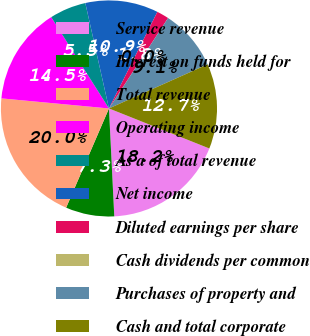Convert chart to OTSL. <chart><loc_0><loc_0><loc_500><loc_500><pie_chart><fcel>Service revenue<fcel>Interest on funds held for<fcel>Total revenue<fcel>Operating income<fcel>As a of total revenue<fcel>Net income<fcel>Diluted earnings per share<fcel>Cash dividends per common<fcel>Purchases of property and<fcel>Cash and total corporate<nl><fcel>18.18%<fcel>7.27%<fcel>20.0%<fcel>14.54%<fcel>5.46%<fcel>10.91%<fcel>1.82%<fcel>0.0%<fcel>9.09%<fcel>12.73%<nl></chart> 